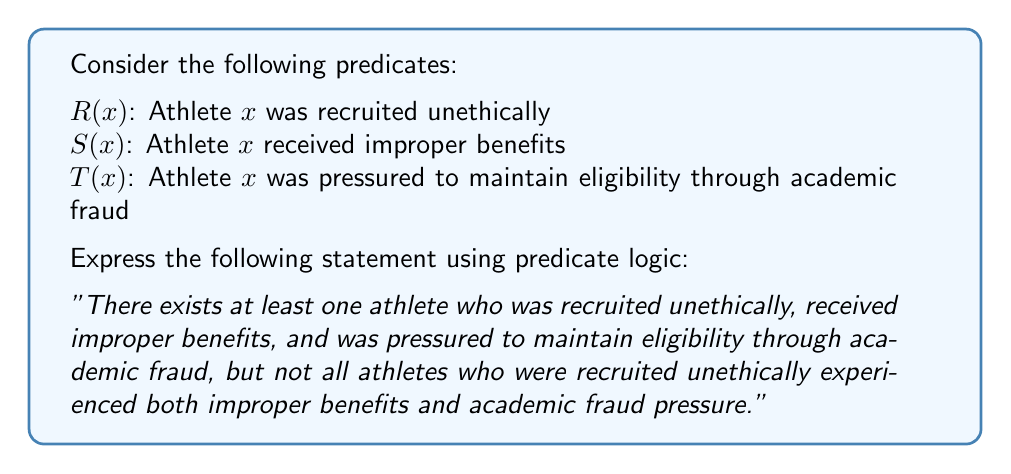What is the answer to this math problem? To express this statement using predicate logic, we need to break it down into two parts:

1. There exists at least one athlete who satisfies all three conditions:
   $\exists x(R(x) \wedge S(x) \wedge T(x))$

2. It is not the case that all athletes who were recruited unethically experienced both improper benefits and academic fraud pressure:
   $\neg \forall x(R(x) \rightarrow (S(x) \wedge T(x)))$

To combine these two statements, we use the logical conjunction (AND) operator:

$$(\exists x(R(x) \wedge S(x) \wedge T(x))) \wedge (\neg \forall x(R(x) \rightarrow (S(x) \wedge T(x))))$$

This logical expression captures the entire statement, asserting that there is at least one athlete who experienced all three unethical practices while also stating that not all unethically recruited athletes experienced both improper benefits and academic fraud pressure.
Answer: $$(\exists x(R(x) \wedge S(x) \wedge T(x))) \wedge (\neg \forall x(R(x) \rightarrow (S(x) \wedge T(x))))$$ 